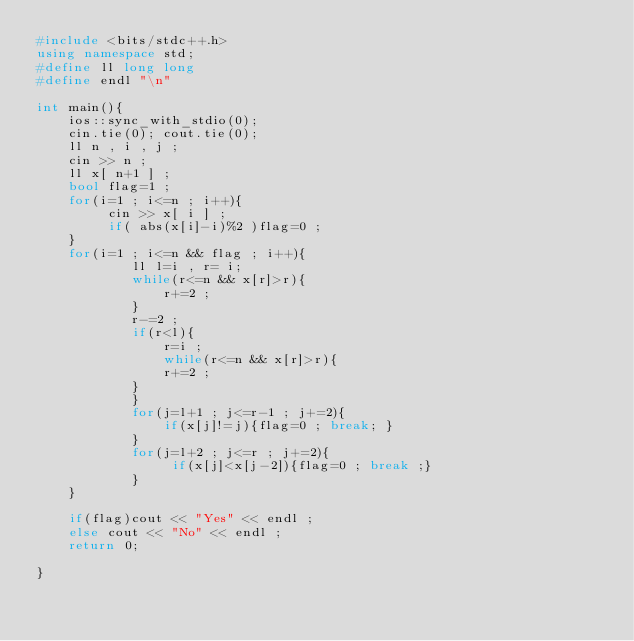<code> <loc_0><loc_0><loc_500><loc_500><_C++_>#include <bits/stdc++.h>
using namespace std;
#define ll long long
#define endl "\n"

int main(){
    ios::sync_with_stdio(0);
    cin.tie(0); cout.tie(0);
    ll n , i , j ;
    cin >> n ;
    ll x[ n+1 ] ;
    bool flag=1 ;
    for(i=1 ; i<=n ; i++){
         cin >> x[ i ] ;
         if( abs(x[i]-i)%2 )flag=0 ;
    }
    for(i=1 ; i<=n && flag ; i++){
            ll l=i , r= i;
            while(r<=n && x[r]>r){
                r+=2 ;
            }
            r-=2 ;
            if(r<l){
                r=i ;
                while(r<=n && x[r]>r){
                r+=2 ;
            }
            }
            for(j=l+1 ; j<=r-1 ; j+=2){
                if(x[j]!=j){flag=0 ; break; }
            }
            for(j=l+2 ; j<=r ; j+=2){
                 if(x[j]<x[j-2]){flag=0 ; break ;}
            }       
    }
    
    if(flag)cout << "Yes" << endl ;
    else cout << "No" << endl ;
    return 0;
    
}
</code> 